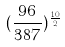Convert formula to latex. <formula><loc_0><loc_0><loc_500><loc_500>( \frac { 9 6 } { 3 8 7 } ) ^ { \frac { 1 0 } { 2 } }</formula> 